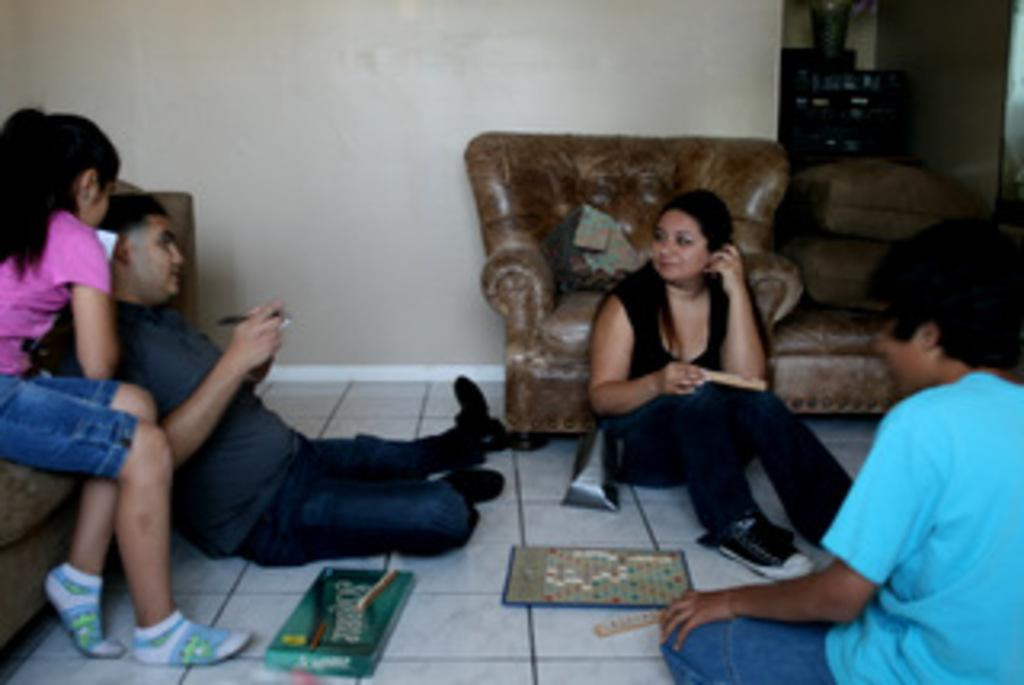What type of structure can be seen in the image? There is a wall in the image. What type of furniture is present in the image? There is a sofa in the image. What are the people in the image doing? The people are sitting on the sofa. Can you tell me how many governors are sitting on the sofa in the image? There is no governor present in the image; it only shows people sitting on the sofa. What type of paper can be seen floating in the ocean in the image? There is no ocean or paper present in the image; it only features a wall, a sofa, and people sitting on the sofa. 